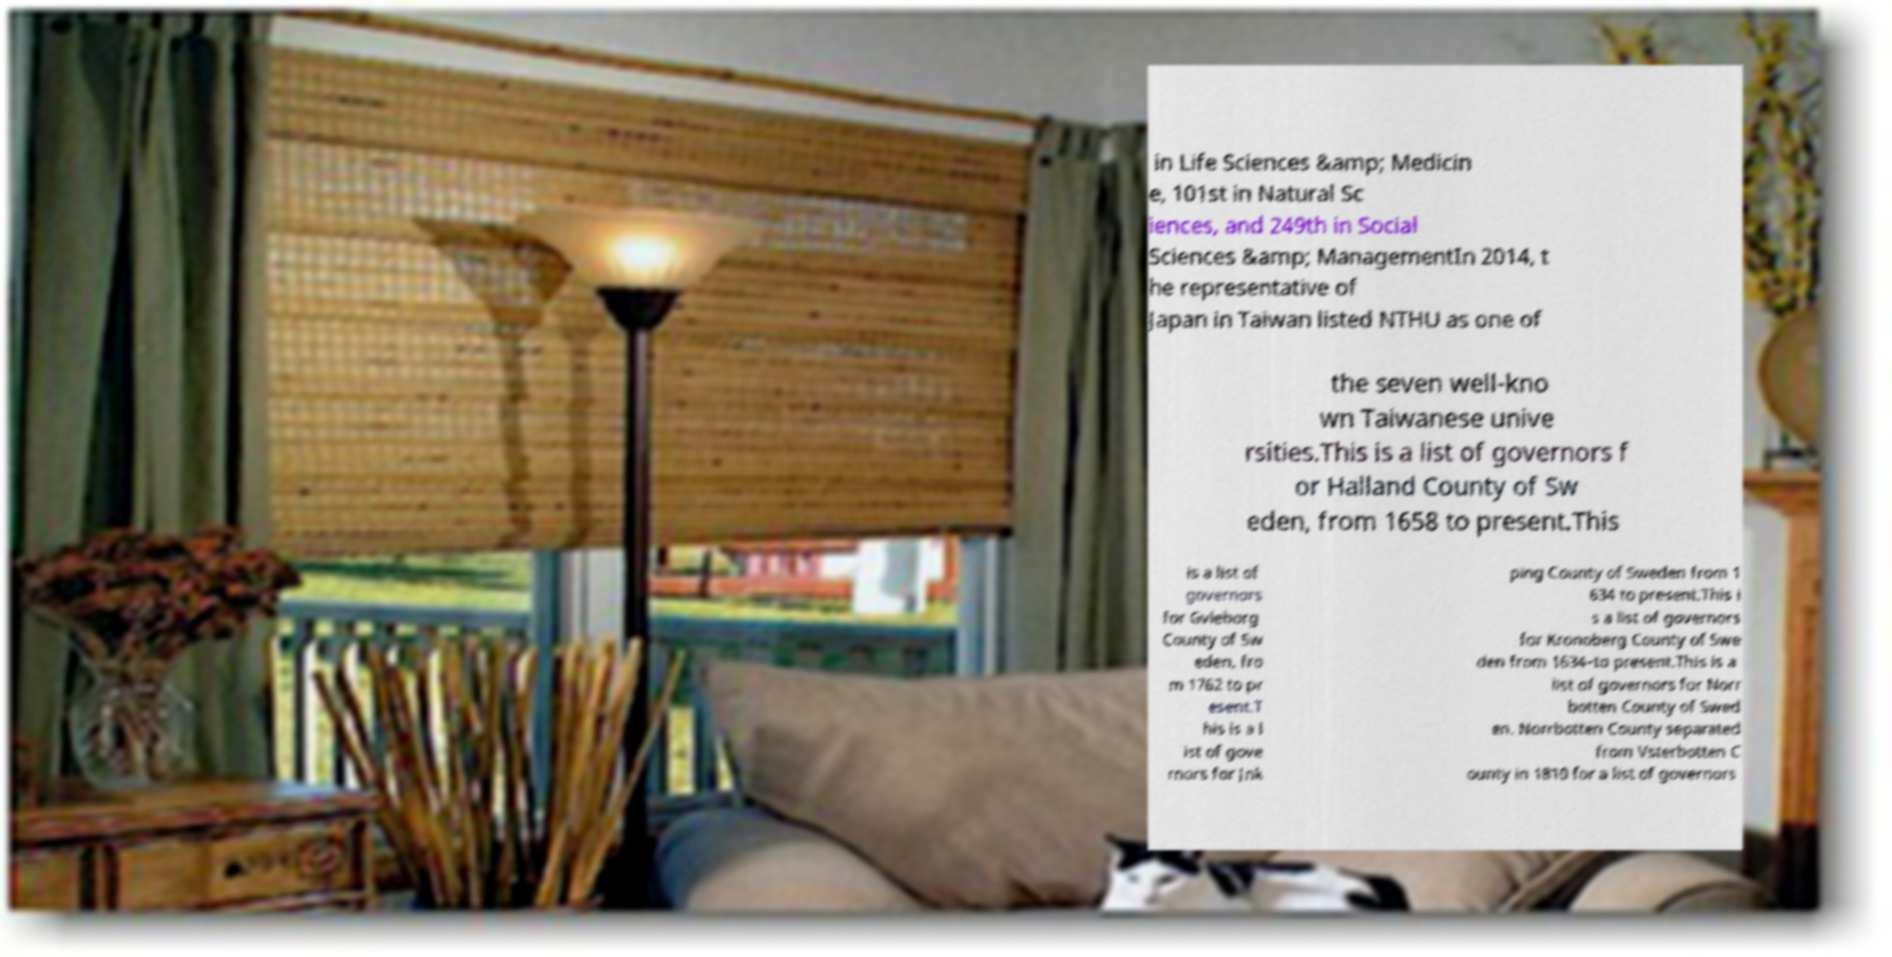Please read and relay the text visible in this image. What does it say? in Life Sciences &amp; Medicin e, 101st in Natural Sc iences, and 249th in Social Sciences &amp; ManagementIn 2014, t he representative of Japan in Taiwan listed NTHU as one of the seven well-kno wn Taiwanese unive rsities.This is a list of governors f or Halland County of Sw eden, from 1658 to present.This is a list of governors for Gvleborg County of Sw eden, fro m 1762 to pr esent.T his is a l ist of gove rnors for Jnk ping County of Sweden from 1 634 to present.This i s a list of governors for Kronoberg County of Swe den from 1634–to present.This is a list of governors for Norr botten County of Swed en. Norrbotten County separated from Vsterbotten C ounty in 1810 for a list of governors 